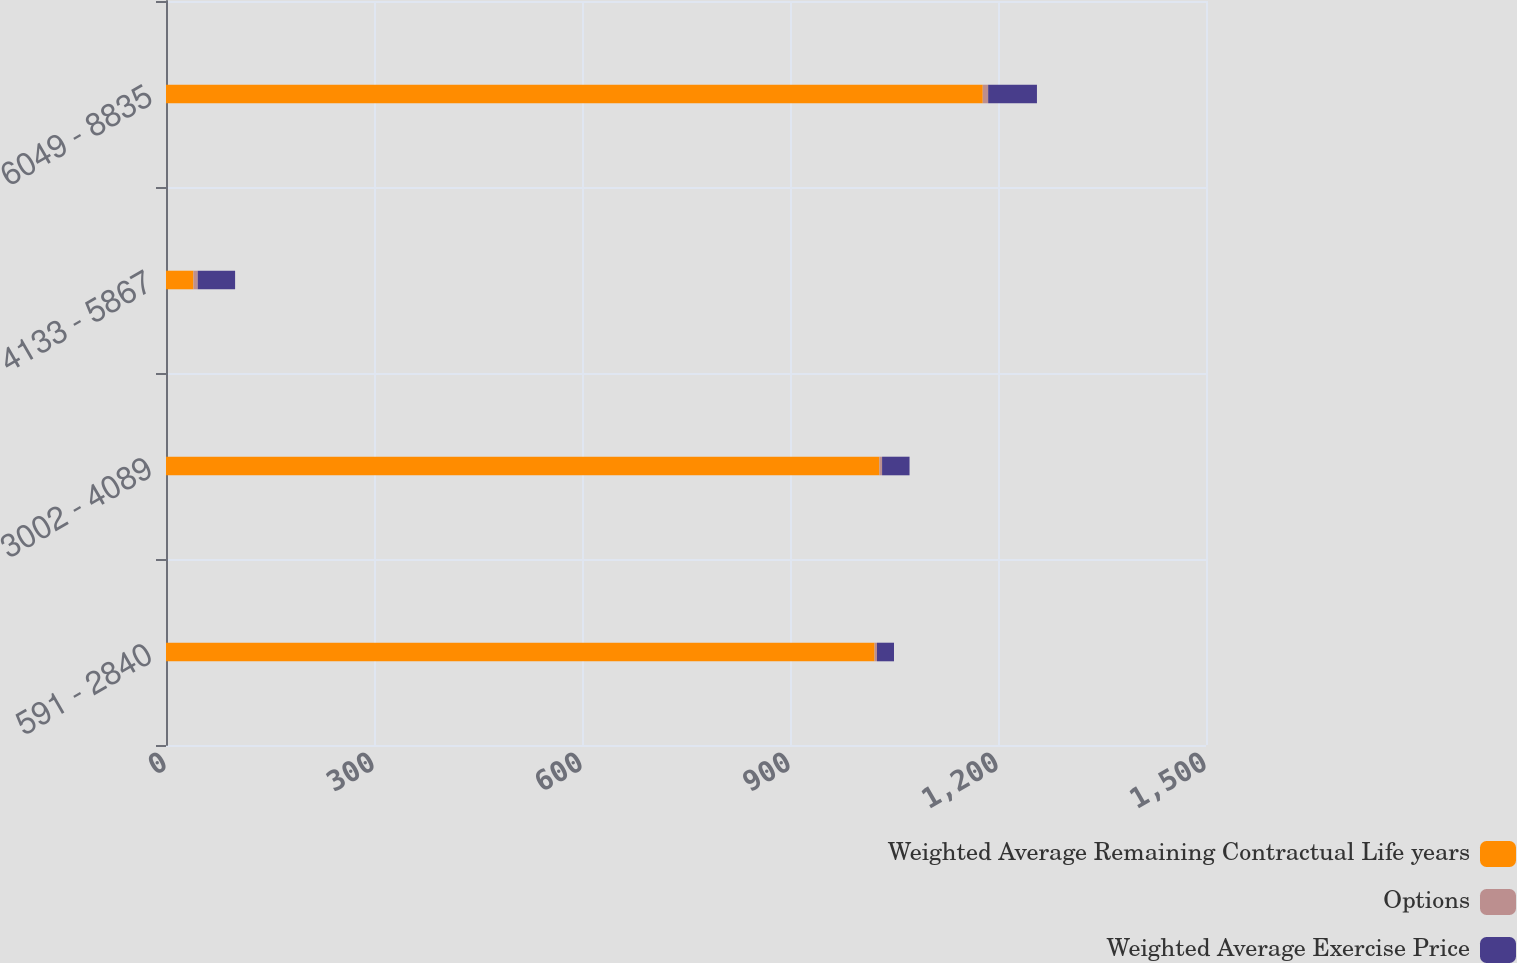Convert chart to OTSL. <chart><loc_0><loc_0><loc_500><loc_500><stacked_bar_chart><ecel><fcel>591 - 2840<fcel>3002 - 4089<fcel>4133 - 5867<fcel>6049 - 8835<nl><fcel>Weighted Average Remaining Contractual Life years<fcel>1022<fcel>1029<fcel>39.6<fcel>1178<nl><fcel>Options<fcel>3.52<fcel>3.81<fcel>6.15<fcel>7.81<nl><fcel>Weighted Average Exercise Price<fcel>24.51<fcel>39.6<fcel>53.92<fcel>70.37<nl></chart> 